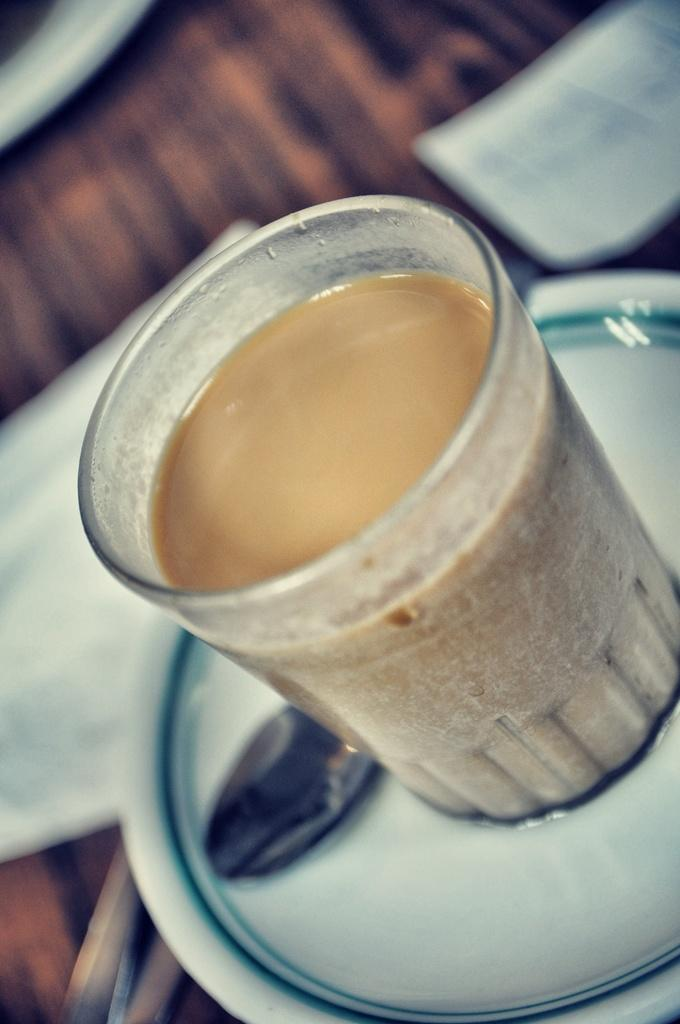What is in the glass that is visible in the image? There is a glass containing tea in the image. Where is the glass placed in the image? The glass is on a plate in the image. What utensil is present on the plate? There is a spoon on the plate. How many pigs are visible in the image? There are no pigs present in the image. Where is the faucet located in the image? There is no faucet present in the image. 